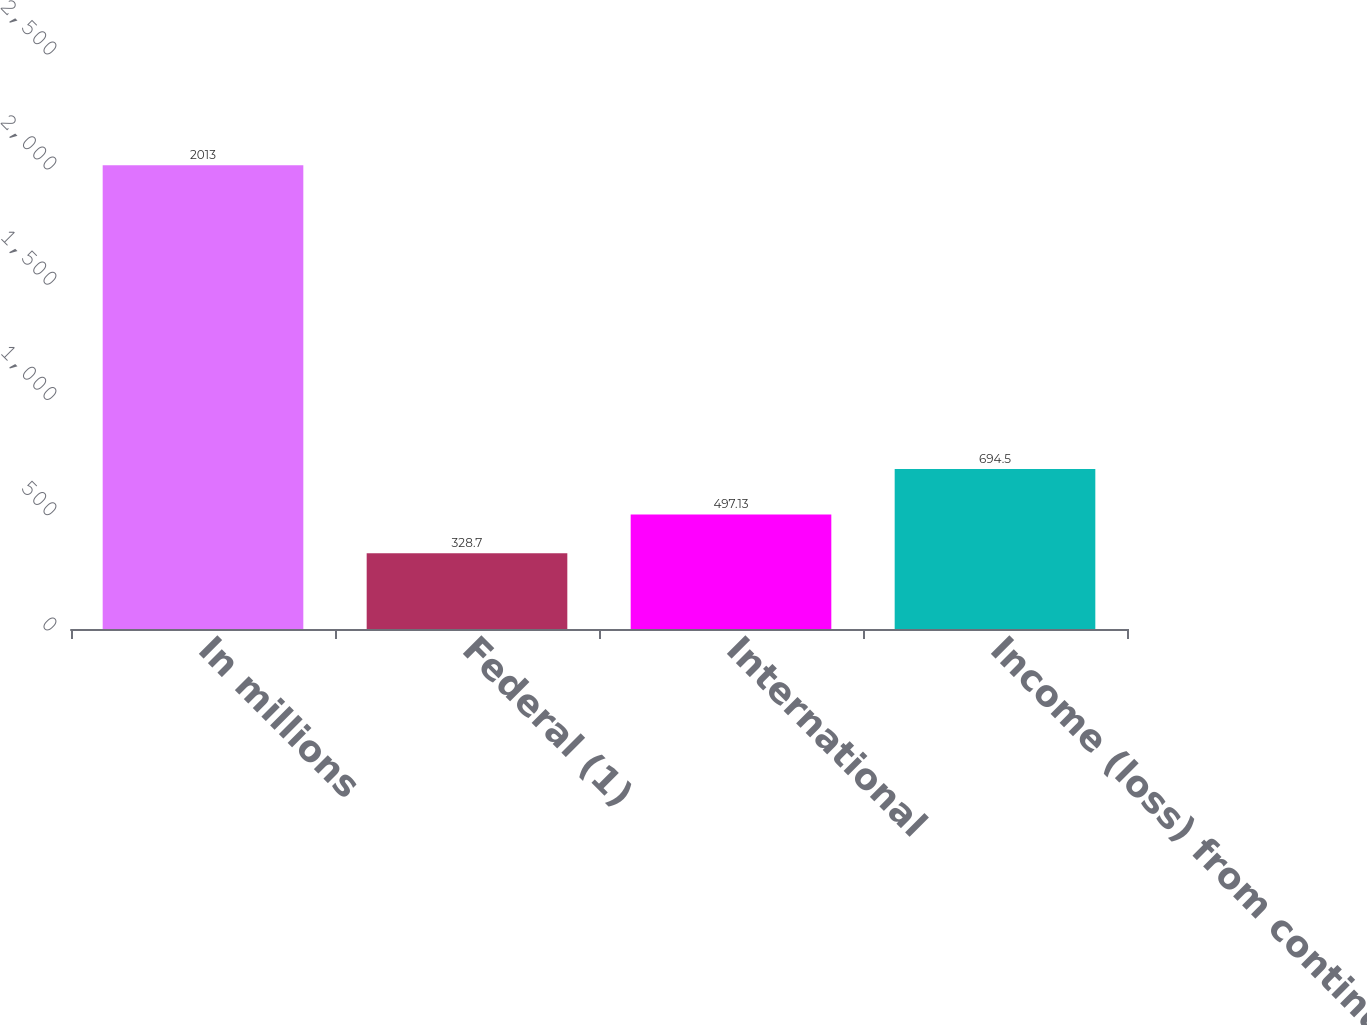Convert chart. <chart><loc_0><loc_0><loc_500><loc_500><bar_chart><fcel>In millions<fcel>Federal (1)<fcel>International<fcel>Income (loss) from continuing<nl><fcel>2013<fcel>328.7<fcel>497.13<fcel>694.5<nl></chart> 